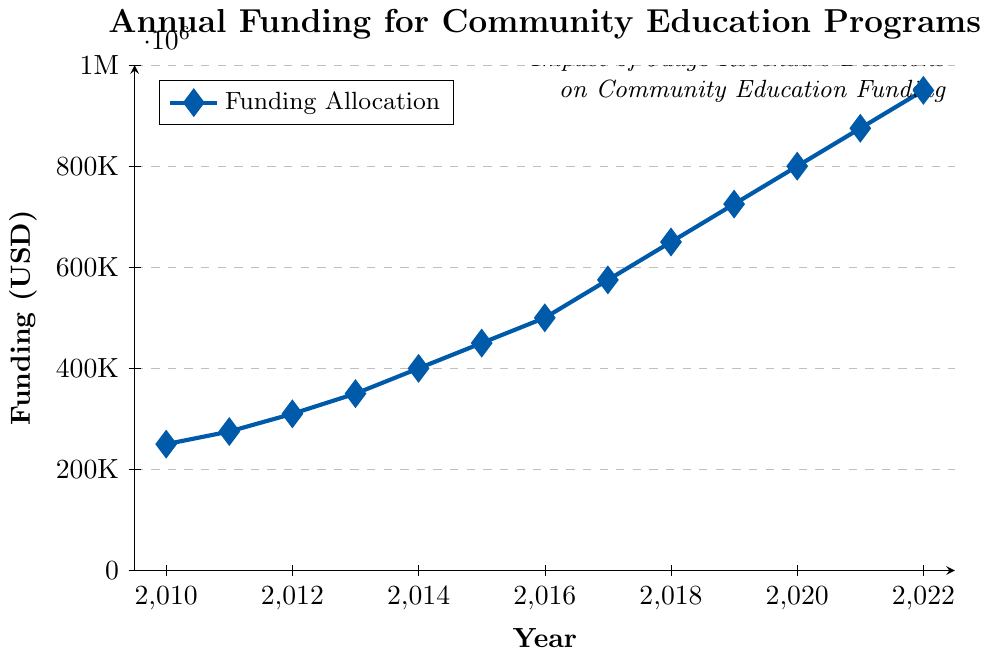What's the funding allocated in 2015? We can locate the point corresponding to the year 2015 on the x-axis and then see the associated funding value on the y-axis, which is marked 450,000.
Answer: 450,000 Between which two consecutive years was the increase in funding the greatest? Determine the differences in funding between each pair of consecutive years, then compare them. The greatest increase occurs between 2016 and 2017, where the funding jumps from 500,000 to 575,000 (an increase of 75,000).
Answer: 2016 and 2017 What is the average annual funding increase from 2010 to 2022? First, calculate the total increase in funding from 2010 to 2022, which is 950,000 - 250,000 = 700,000. Then divide by the number of intervals, which is 2022 - 2010 = 12. The average annual increase is 700,000 / 12.
Answer: 58,333.33 How much did the funding increase from 2019 to 2022? Locate the funding values for 2019 and 2022 which are 725,000 and 950,000 respectively. Subtract the 2019 value from the 2022 value: 950,000 - 725,000 = 225,000.
Answer: 225,000 Was there any year when the funding was stagnant or did not increase compared to the previous year? Inspect the graph to see if there’s any flat line or repeated funding value. All years show an increase compared to the previous year.
Answer: No How much more funding was allocated in 2022 compared to 2014? Locate the funding values for 2022 and 2014 which are 950,000 and 400,000 respectively. Subtract the 2014 value from the 2022 value: 950,000 - 400,000 = 550,000.
Answer: 550,000 Is the funding allocation increasing at a constant rate each year? By observing the graph, we can see that the slope between each point is not constant, suggesting that the funding increase rate varies each year.
Answer: No By how much did the funding increase on average between 2018 and 2022 per year? Calculate the total increase from 2018 to 2022, which is 950,000 - 650,000 = 300,000. Then divide by the number of intervals, which is 2022 - 2018 = 4. The average increase is 300,000 / 4.
Answer: 75,000 